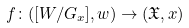<formula> <loc_0><loc_0><loc_500><loc_500>f \colon ( [ W / G _ { x } ] , w ) \to ( { \mathfrak { X } } , x )</formula> 